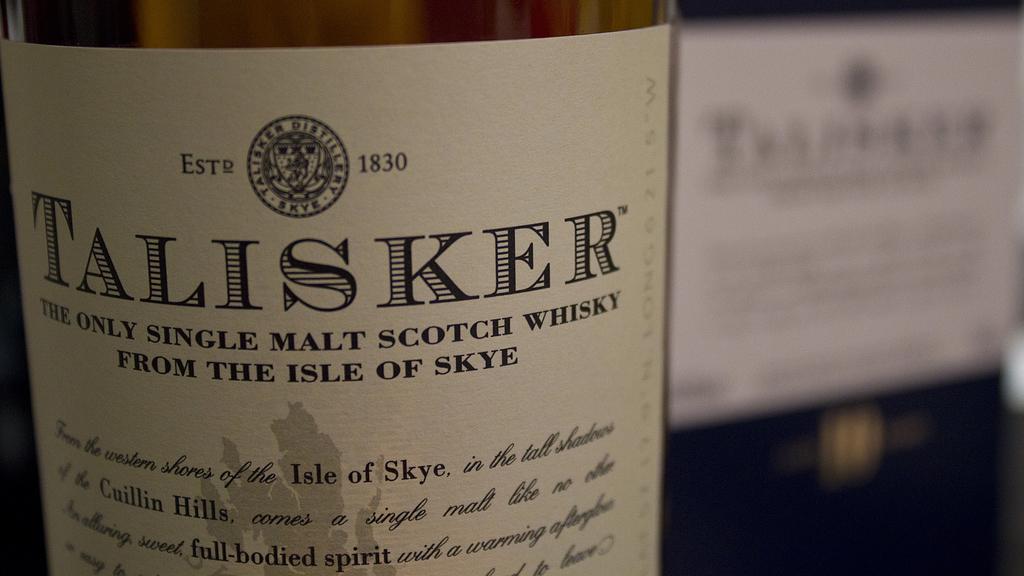What year was the business established?
Offer a terse response. 1830. 